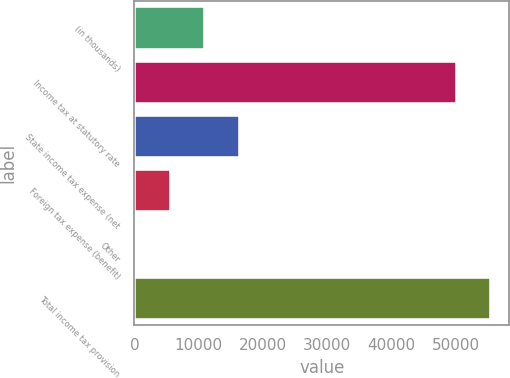Convert chart to OTSL. <chart><loc_0><loc_0><loc_500><loc_500><bar_chart><fcel>(in thousands)<fcel>Income tax at statutory rate<fcel>State income tax expense (net<fcel>Foreign tax expense (benefit)<fcel>Other<fcel>Total income tax provision<nl><fcel>11043<fcel>50241<fcel>16355.5<fcel>5730.5<fcel>418<fcel>55553.5<nl></chart> 